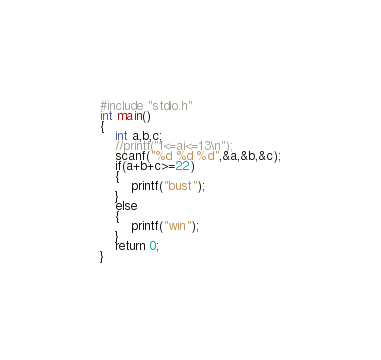<code> <loc_0><loc_0><loc_500><loc_500><_C_>#include "stdio.h"
int main()
{
	int a,b,c;
	//printf("1<=ai<=13\n");
	scanf("%d %d %d",&a,&b,&c);
	if(a+b+c>=22)
	{
		printf("bust");
	}
	else
	{
		printf("win");
	}
	return 0;
}
</code> 